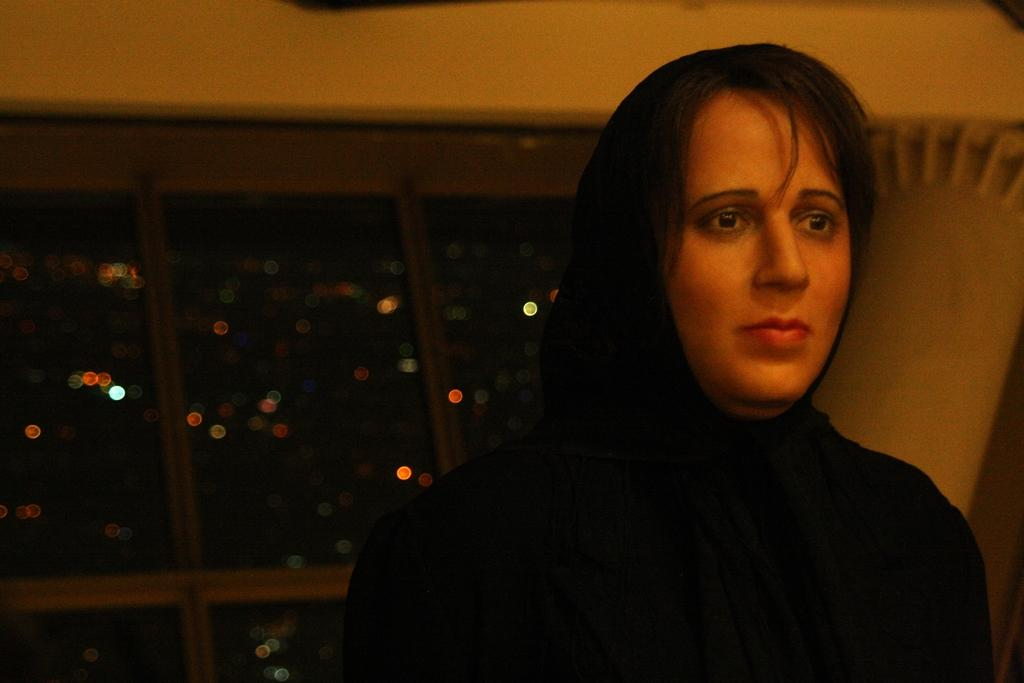Who is present in the image? There is a woman in the image. What is the woman wearing? The woman is wearing a black dress. What can be seen in the background of the image? There is a wall and a window in the background of the image. What is visible through the window? Lights are visible through the window. What word is being cut with the scissors in the image? There are no scissors or words present in the image. What type of range can be seen in the image? There is no range visible in the image. 